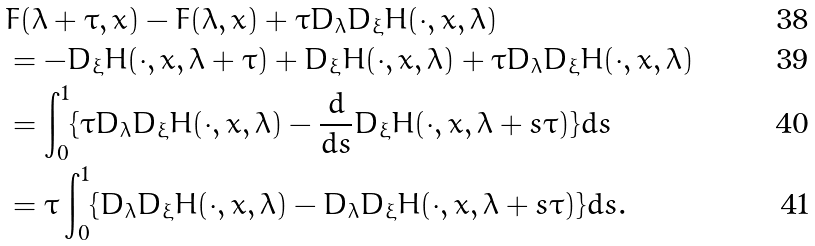Convert formula to latex. <formula><loc_0><loc_0><loc_500><loc_500>& F ( \lambda + \tau , x ) - F ( \lambda , x ) + \tau D _ { \lambda } D _ { \xi } H ( \cdot , x , \lambda ) \\ & = - D _ { \xi } H ( \cdot , x , \lambda + \tau ) + D _ { \xi } H ( \cdot , x , \lambda ) + \tau D _ { \lambda } D _ { \xi } H ( \cdot , x , \lambda ) \\ & = \int _ { 0 } ^ { 1 } \{ \tau D _ { \lambda } D _ { \xi } H ( \cdot , x , \lambda ) - \frac { d } { d s } D _ { \xi } H ( \cdot , x , \lambda + s \tau ) \} d s \\ & = \tau \int _ { 0 } ^ { 1 } \{ D _ { \lambda } D _ { \xi } H ( \cdot , x , \lambda ) - D _ { \lambda } D _ { \xi } H ( \cdot , x , \lambda + s \tau ) \} d s .</formula> 